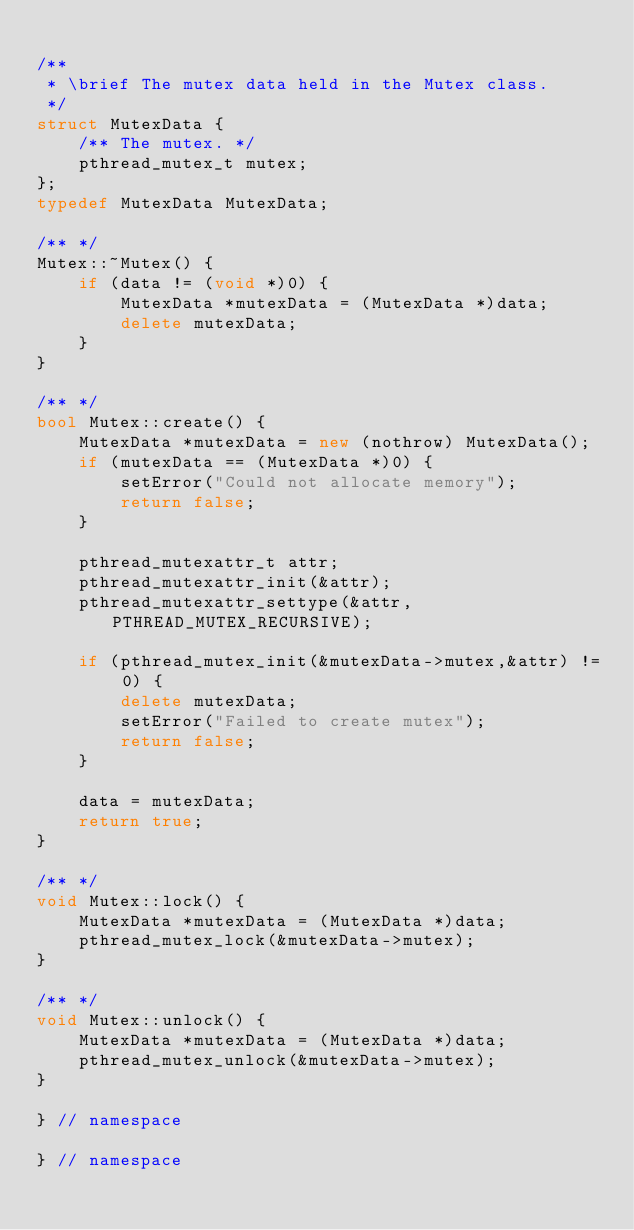<code> <loc_0><loc_0><loc_500><loc_500><_C++_>    
/**
 * \brief The mutex data held in the Mutex class.
 */
struct MutexData {
    /** The mutex. */
    pthread_mutex_t mutex;
};
typedef MutexData MutexData;
    
/** */
Mutex::~Mutex() {
    if (data != (void *)0) {
        MutexData *mutexData = (MutexData *)data;    
        delete mutexData;
    }
}

/** */
bool Mutex::create() {
    MutexData *mutexData = new (nothrow) MutexData();
    if (mutexData == (MutexData *)0) {
        setError("Could not allocate memory");
        return false;
    }
    
    pthread_mutexattr_t attr;
    pthread_mutexattr_init(&attr);
    pthread_mutexattr_settype(&attr,PTHREAD_MUTEX_RECURSIVE);
    
    if (pthread_mutex_init(&mutexData->mutex,&attr) != 0) { 
        delete mutexData;
        setError("Failed to create mutex");
        return false;
    }
    
    data = mutexData;
    return true;
}

/** */
void Mutex::lock() {
    MutexData *mutexData = (MutexData *)data; 
    pthread_mutex_lock(&mutexData->mutex);
}

/** */
void Mutex::unlock() {
    MutexData *mutexData = (MutexData *)data; 
    pthread_mutex_unlock(&mutexData->mutex);
}

} // namespace

} // namespace
</code> 